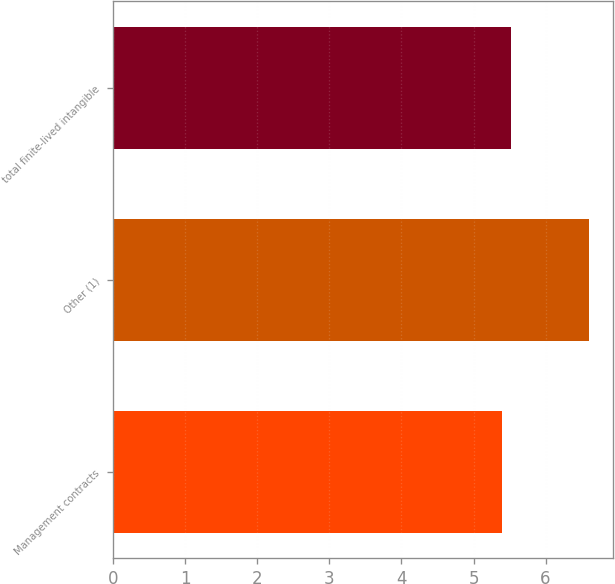Convert chart to OTSL. <chart><loc_0><loc_0><loc_500><loc_500><bar_chart><fcel>Management contracts<fcel>Other (1)<fcel>total finite-lived intangible<nl><fcel>5.4<fcel>6.6<fcel>5.52<nl></chart> 